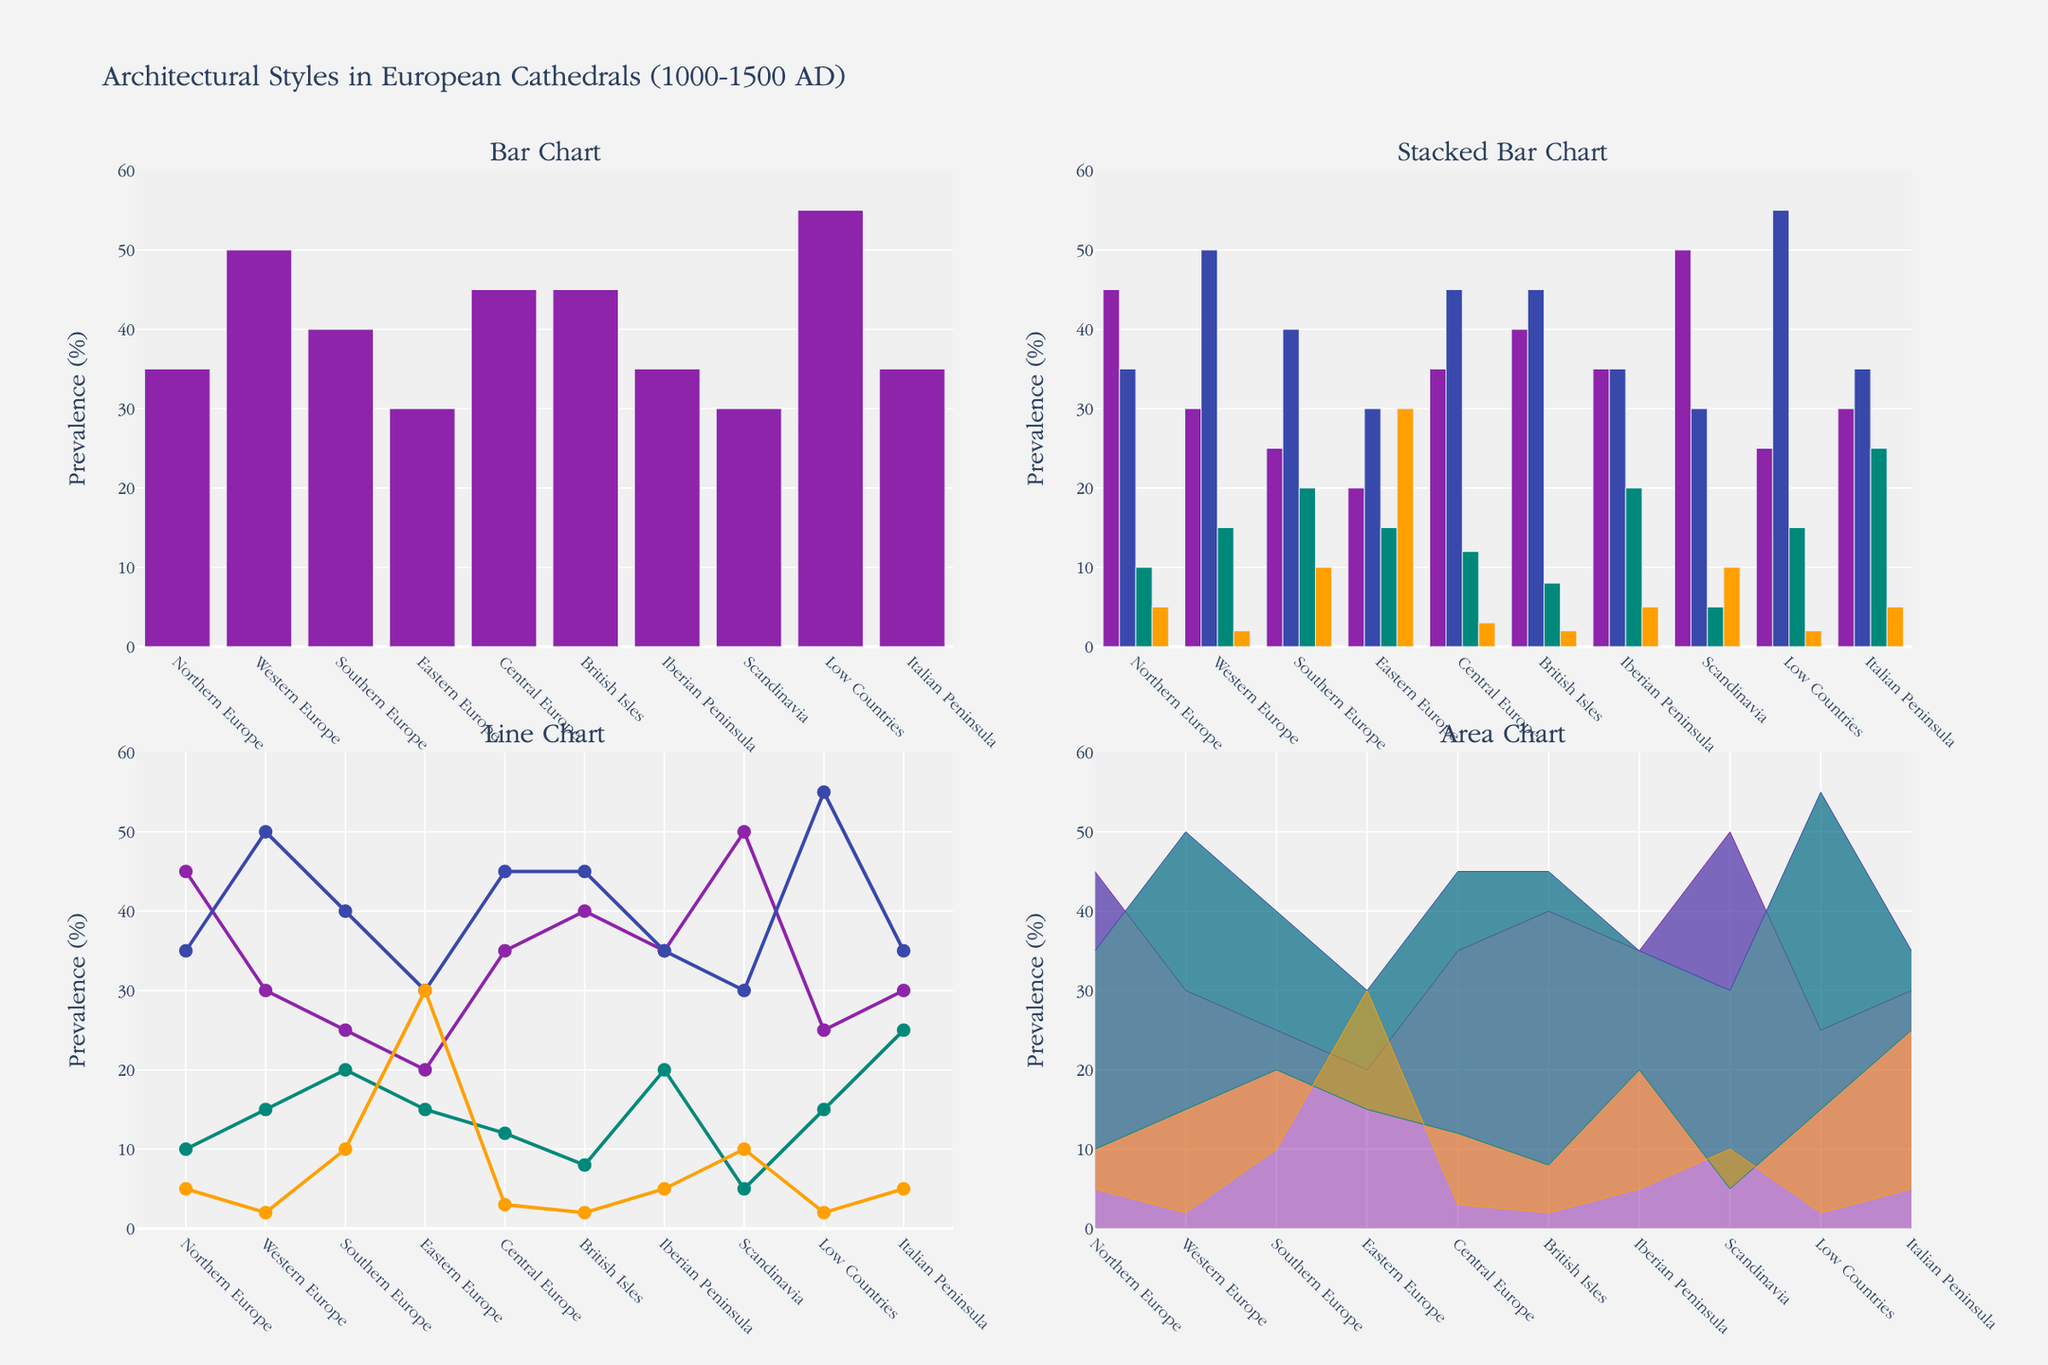Which architectural style has the highest prevalence in Western Europe? Look at each subplot for Western Europe: the Bar Chart, Stacked Bar Chart, Line Chart, and Area Chart. Identify the one with the highest value among the different architectural styles.
Answer: Gothic Which region shows the highest prevalence of Gothic architecture according to the Bar Chart? Focus on the Bar Chart subplot. Identify the bar with the highest value for Gothic architecture by comparing the heights of the bars for each region.
Answer: Low Countries What is the total prevalence of Romanesque and Renaissance styles in Southern Europe based on the Stacked Bar Chart? Locate Southern Europe in the Stacked Bar Chart. Find the values for Romanesque and Renaissance styles and sum them up.
Answer: 25 + 20 = 45 Which two regions have the same prevalence of Gothic architecture according to the Line Chart? Check the Line Chart subplot, focusing on the Gothic architecture lines. Look for two regions where the y-values (prevalence percentages) are the same.
Answer: British Isles and Central Europe Which architectural style shows a decreasing trend from Northern to Southern Europe in the Area Chart? Examine the Area Chart for changes in the filled areas of each style from Northern to Southern Europe. Identify the one that decreases in filled area as you move from Northern to Southern Europe.
Answer: Romanesque What is the combined prevalence of Byzantine architecture in Eastern Europe and Northern Europe from the Line Chart? Find the prevalence values for Byzantine architecture in Eastern Europe and Northern Europe from the Line Chart and sum them up.
Answer: 30 + 5 = 35 Between the Bar Chart and the Stacked Bar Chart, which one offers more detailed insights into the relative prevalence of all architectural styles in each region? Compare the two subplots. The Bar Chart shows only one style (Gothic), whereas the Stacked Bar Chart shows multiple styles within each region, stacking them to reflect their combined prevalence.
Answer: Stacked Bar Chart Which region has the smallest difference between Romanesque and Gothic styles according to the Line Chart? Locate the lines for Romanesque and Gothic styles in the Line Chart. Calculate the differences for each region and find the smallest one.
Answer: British Isles In the Area Chart, which architectural style remains fairly consistent across the regions? Analyze the Area Chart for any style that maintains a relatively flat line, indicating consistent prevalence across different regions.
Answer: Renaissance Which region has a higher prevalence of Renaissance architecture than Byzantine architecture, as seen in the Stacked Bar Chart? In the Stacked Bar Chart, compare the heights of the bars for Renaissance and Byzantine styles within each region. Identify the region where Renaissance is higher than Byzantine.
Answer: Southern Europe 